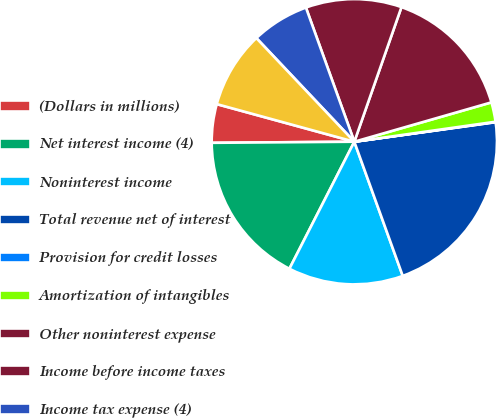<chart> <loc_0><loc_0><loc_500><loc_500><pie_chart><fcel>(Dollars in millions)<fcel>Net interest income (4)<fcel>Noninterest income<fcel>Total revenue net of interest<fcel>Provision for credit losses<fcel>Amortization of intangibles<fcel>Other noninterest expense<fcel>Income before income taxes<fcel>Income tax expense (4)<fcel>Net income<nl><fcel>4.37%<fcel>17.36%<fcel>13.03%<fcel>21.68%<fcel>0.05%<fcel>2.21%<fcel>15.19%<fcel>10.87%<fcel>6.54%<fcel>8.7%<nl></chart> 